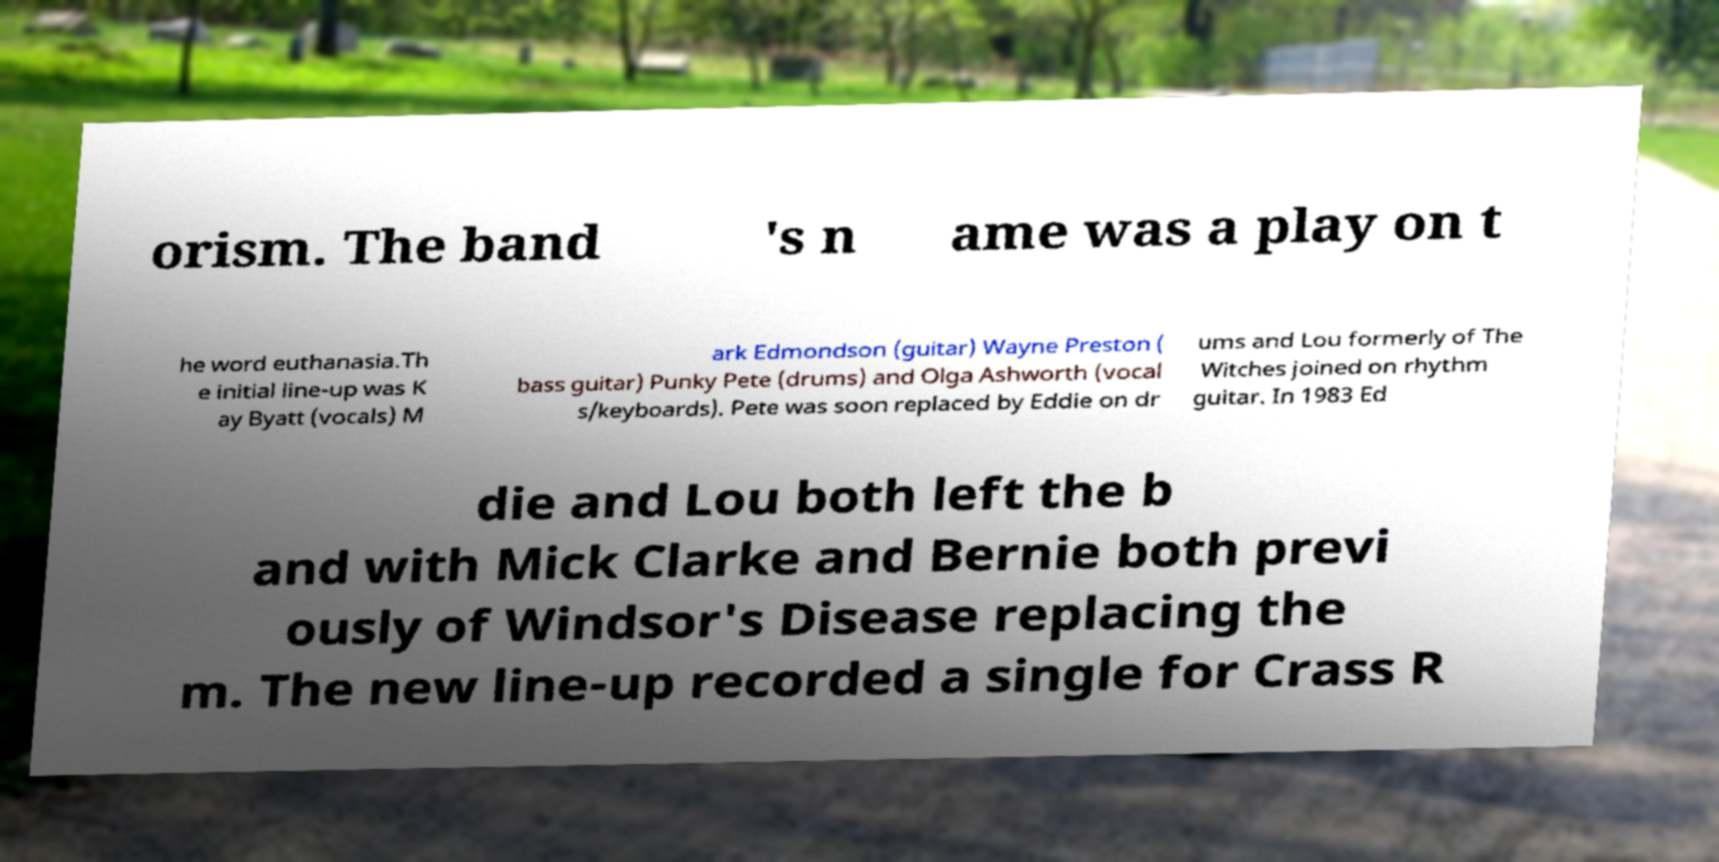What messages or text are displayed in this image? I need them in a readable, typed format. orism. The band 's n ame was a play on t he word euthanasia.Th e initial line-up was K ay Byatt (vocals) M ark Edmondson (guitar) Wayne Preston ( bass guitar) Punky Pete (drums) and Olga Ashworth (vocal s/keyboards). Pete was soon replaced by Eddie on dr ums and Lou formerly of The Witches joined on rhythm guitar. In 1983 Ed die and Lou both left the b and with Mick Clarke and Bernie both previ ously of Windsor's Disease replacing the m. The new line-up recorded a single for Crass R 